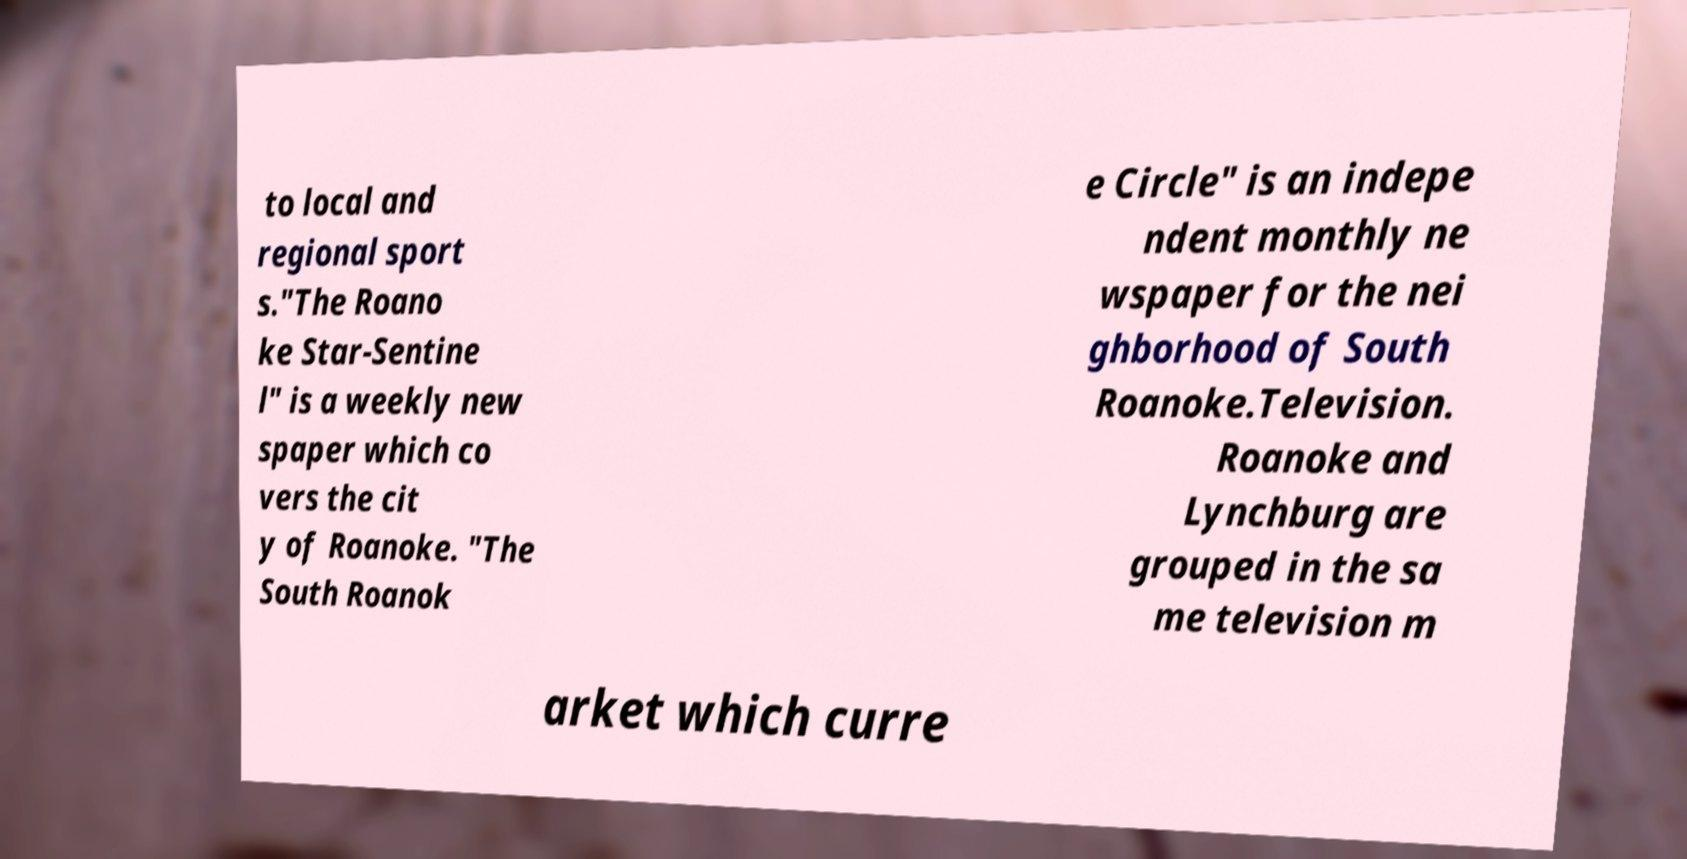Can you accurately transcribe the text from the provided image for me? to local and regional sport s."The Roano ke Star-Sentine l" is a weekly new spaper which co vers the cit y of Roanoke. "The South Roanok e Circle" is an indepe ndent monthly ne wspaper for the nei ghborhood of South Roanoke.Television. Roanoke and Lynchburg are grouped in the sa me television m arket which curre 